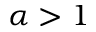<formula> <loc_0><loc_0><loc_500><loc_500>\alpha > 1</formula> 